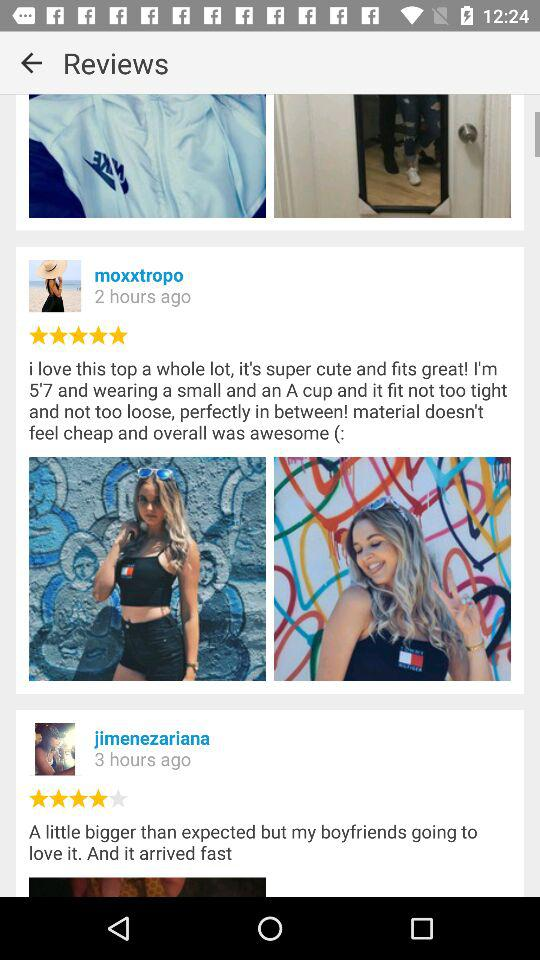What is the star rating on the post updated by moxxtropo? The star rating is "5 stars". 